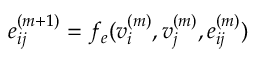<formula> <loc_0><loc_0><loc_500><loc_500>e _ { i j } ^ { ( m + 1 ) } = f _ { e } ( v _ { i } ^ { ( m ) } , v _ { j } ^ { ( m ) } , e _ { i j } ^ { ( m ) } )</formula> 